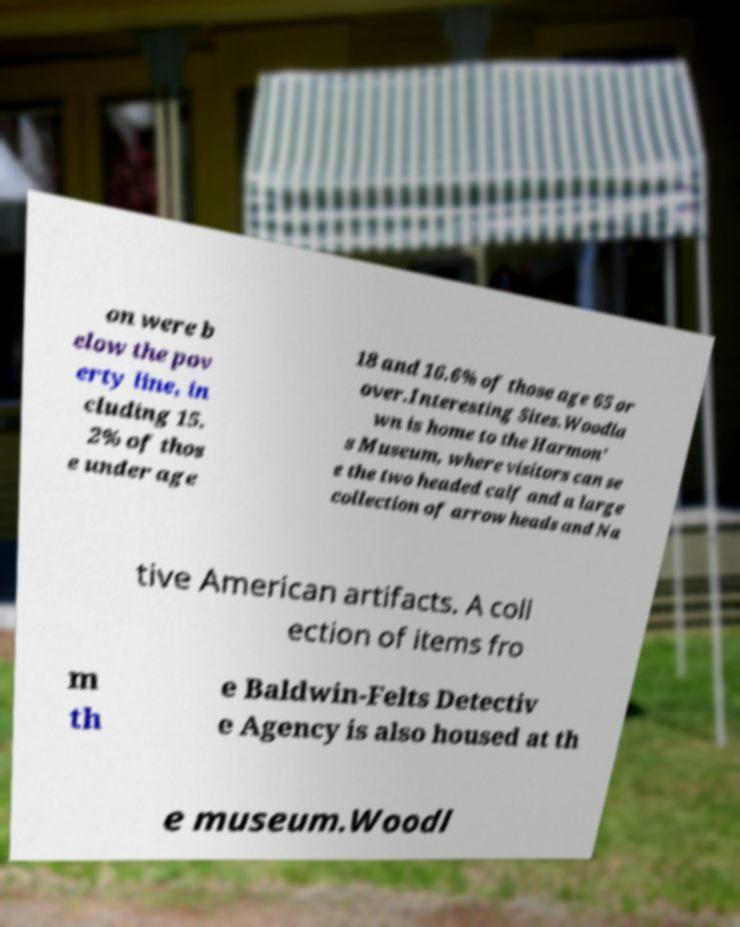Can you read and provide the text displayed in the image?This photo seems to have some interesting text. Can you extract and type it out for me? on were b elow the pov erty line, in cluding 15. 2% of thos e under age 18 and 16.6% of those age 65 or over.Interesting Sites.Woodla wn is home to the Harmon' s Museum, where visitors can se e the two headed calf and a large collection of arrow heads and Na tive American artifacts. A coll ection of items fro m th e Baldwin-Felts Detectiv e Agency is also housed at th e museum.Woodl 